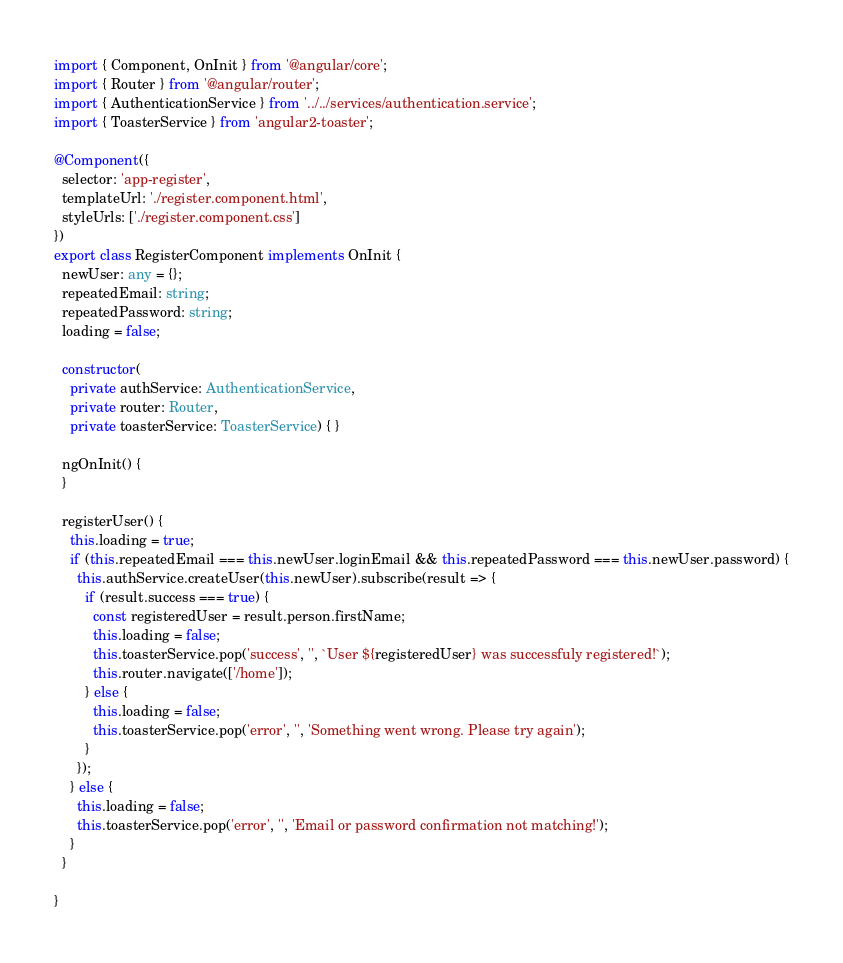<code> <loc_0><loc_0><loc_500><loc_500><_TypeScript_>import { Component, OnInit } from '@angular/core';
import { Router } from '@angular/router';
import { AuthenticationService } from '../../services/authentication.service';
import { ToasterService } from 'angular2-toaster';

@Component({
  selector: 'app-register',
  templateUrl: './register.component.html',
  styleUrls: ['./register.component.css']
})
export class RegisterComponent implements OnInit {
  newUser: any = {};
  repeatedEmail: string;
  repeatedPassword: string;
  loading = false;

  constructor(
    private authService: AuthenticationService,
    private router: Router,
    private toasterService: ToasterService) { }

  ngOnInit() {
  }

  registerUser() {
    this.loading = true;
    if (this.repeatedEmail === this.newUser.loginEmail && this.repeatedPassword === this.newUser.password) {
      this.authService.createUser(this.newUser).subscribe(result => {
        if (result.success === true) {
          const registeredUser = result.person.firstName;
          this.loading = false;
          this.toasterService.pop('success', '', `User ${registeredUser} was successfuly registered!`);
          this.router.navigate(['/home']);
        } else {
          this.loading = false;
          this.toasterService.pop('error', '', 'Something went wrong. Please try again');
        }
      });
    } else {
      this.loading = false;
      this.toasterService.pop('error', '', 'Email or password confirmation not matching!');
    }
  }

}
</code> 